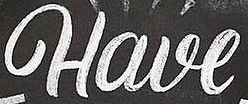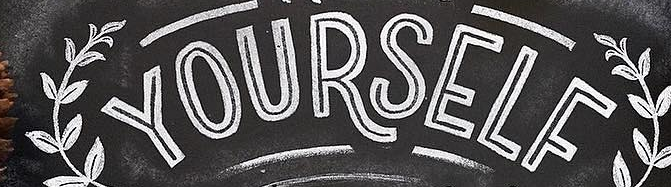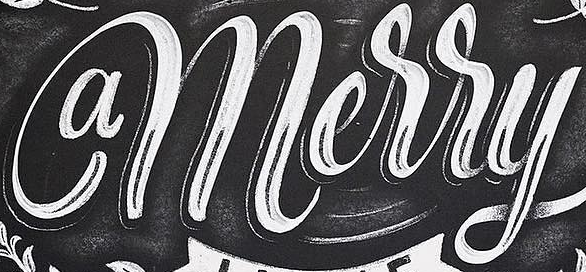Transcribe the words shown in these images in order, separated by a semicolon. Have; YOURSELF; amerry 